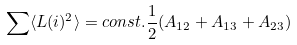Convert formula to latex. <formula><loc_0><loc_0><loc_500><loc_500>\sum \langle L ( i ) ^ { 2 } \rangle = c o n s t . \frac { 1 } { 2 } ( A _ { 1 2 } + A _ { 1 3 } + A _ { 2 3 } )</formula> 